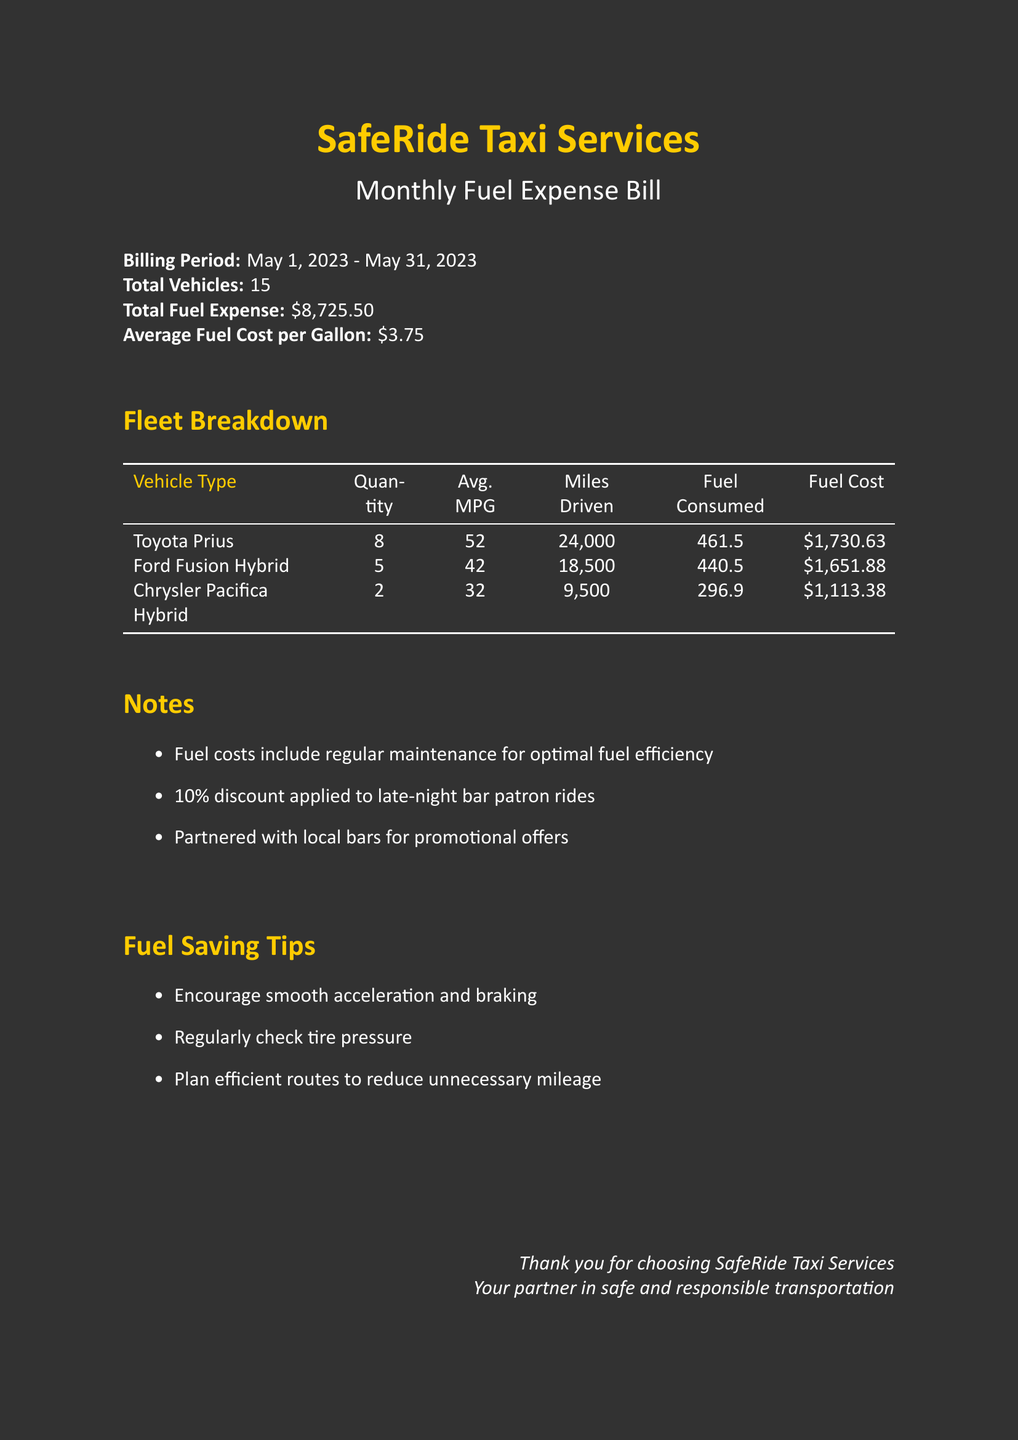what is the billing period? The billing period for the monthly fuel expense bill is specified in the document as May 1, 2023 - May 31, 2023.
Answer: May 1, 2023 - May 31, 2023 what is the total fuel expense? The total fuel expense for the taxi fleet during the billing period is explicitly mentioned in the document.
Answer: $8,725.50 how many Toyota Prius vehicles are in the fleet? The document lists the quantity of each vehicle type in the fleet, specifically stating the number of Toyota Prius vehicles.
Answer: 8 what is the average MPG of the Ford Fusion Hybrid? The average MPG for Ford Fusion Hybrid vehicles is provided in the fleet breakdown section.
Answer: 42 what percentage discount is applied to late-night bar patron rides? The document includes notes on discounts applied to specific rides, indicating the percentage.
Answer: 10% what is the fuel cost for Chrysler Pacifica Hybrid? The document specifies the fuel cost associated with Chrysler Pacifica Hybrid vehicles in the fleet.
Answer: $1,113.38 how many total vehicles are included in the document? The total number of vehicles in the taxi fleet is stated in the introductory section of the document.
Answer: 15 what is the average fuel cost per gallon? The document cites the average fuel cost per gallon, providing this specific financial detail.
Answer: $3.75 what is the total miles driven by all vehicles? To find the total miles driven, one must sum the miles driven for each vehicle type as outlined in the document.
Answer: 51,000 